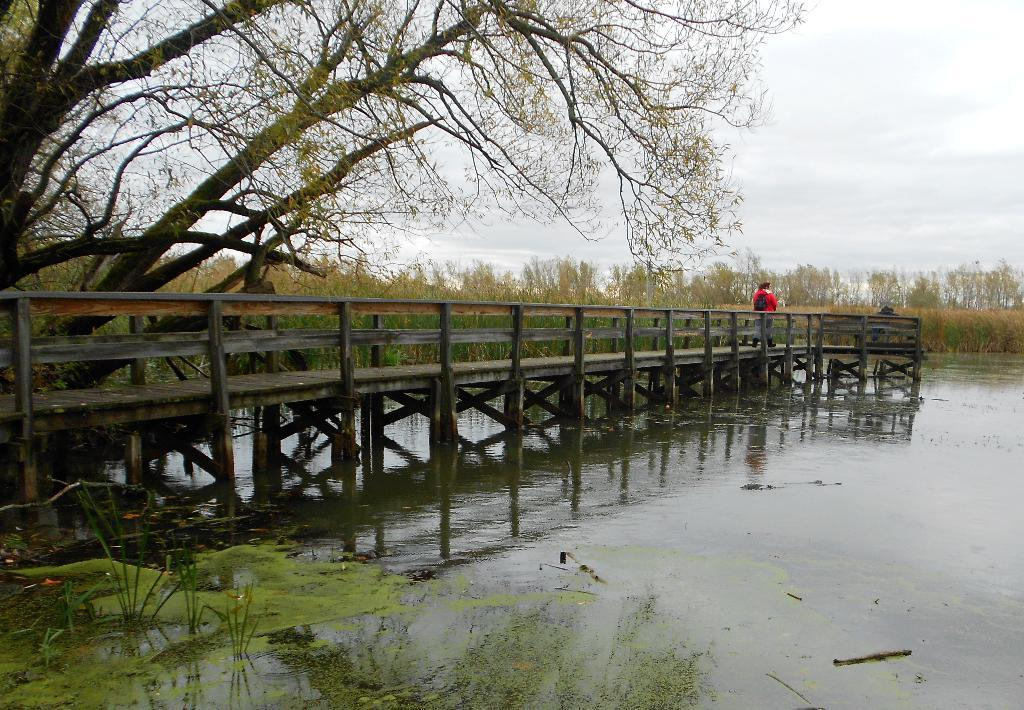What type of structure is present in the image? There is a wooden bridge in the image. What is happening with the water in the image? Water is flowing in the image. Can you describe the appearance of the water? There is algae on the water in the image. What type of vegetation is visible in the image? There are trees in the image. Who or what is on the bridge in the image? There is a person standing on the bridge in the image. What word is being spoken by the ghost in the image? There is no ghost present in the image, so no words can be attributed to a ghost. How many people are visible in the image? There is only one person visible in the image, the one standing on the bridge. 